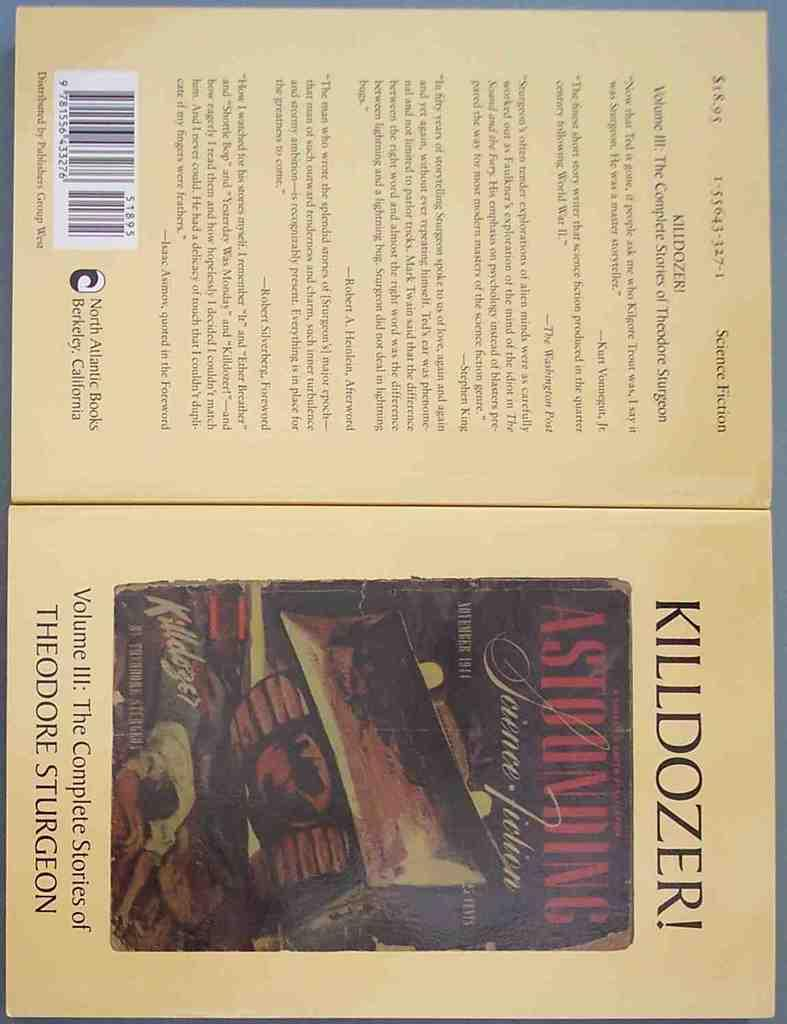<image>
Give a short and clear explanation of the subsequent image. A book cover with the title KILLDOZER Astounding! 